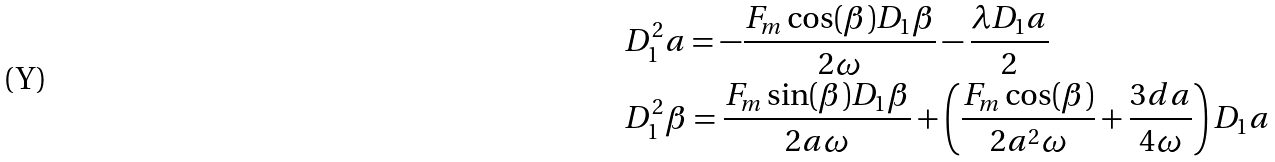<formula> <loc_0><loc_0><loc_500><loc_500>& D _ { 1 } ^ { 2 } a = - \frac { F _ { m } \cos ( \beta ) D _ { 1 } \beta } { 2 \omega } - \frac { \lambda D _ { 1 } a } { 2 } \\ & D _ { 1 } ^ { 2 } \beta = \frac { F _ { m } \sin ( \beta ) D _ { 1 } \beta } { 2 a \omega } + \left ( \frac { F _ { m } \cos ( \beta ) } { 2 a ^ { 2 } \omega } + \frac { 3 d a } { 4 \omega } \right ) D _ { 1 } a</formula> 